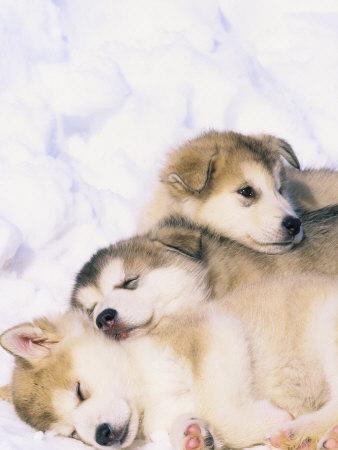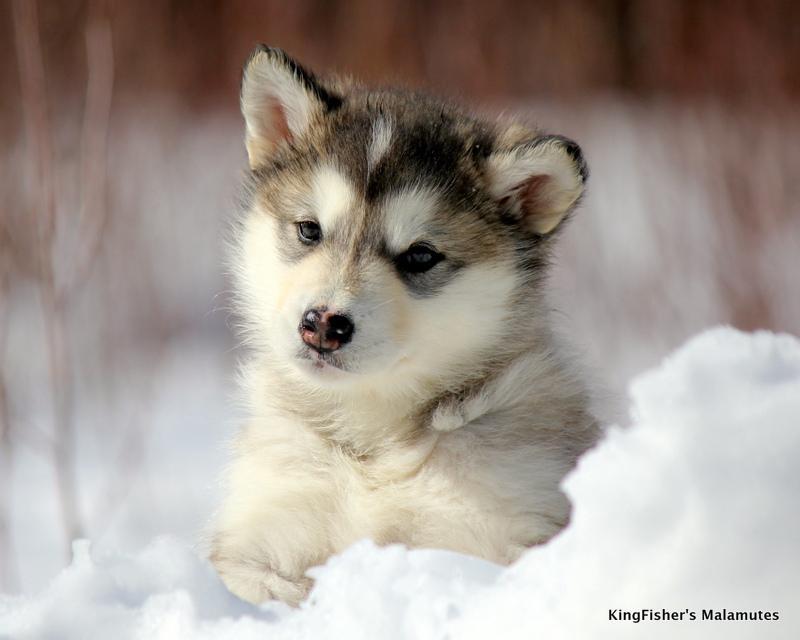The first image is the image on the left, the second image is the image on the right. For the images displayed, is the sentence "At least one photo shows a single dog facing forward, standing on grass." factually correct? Answer yes or no. No. The first image is the image on the left, the second image is the image on the right. Examine the images to the left and right. Is the description "The combined images show four puppies of the same breed in the snow." accurate? Answer yes or no. Yes. 